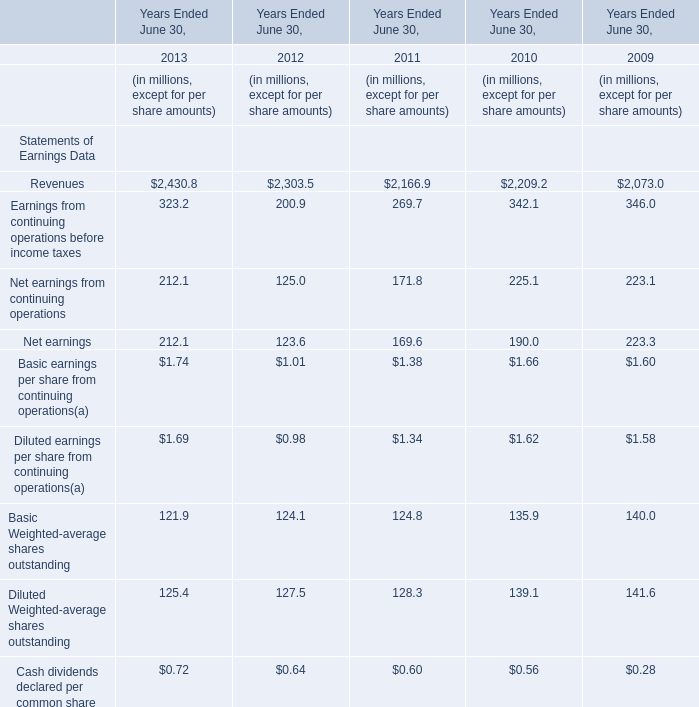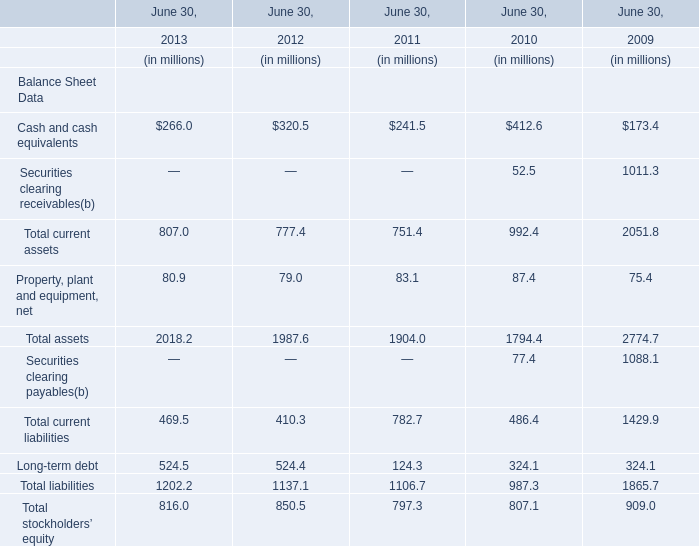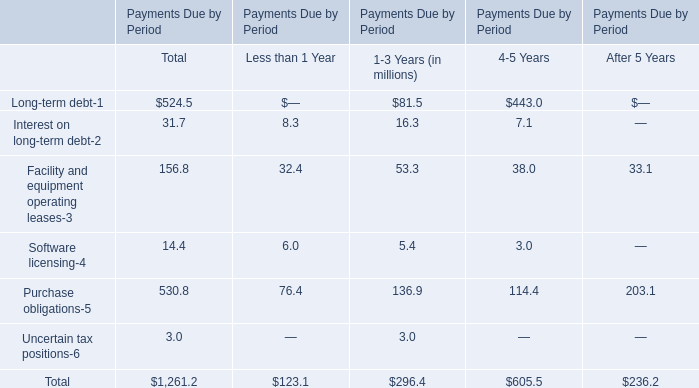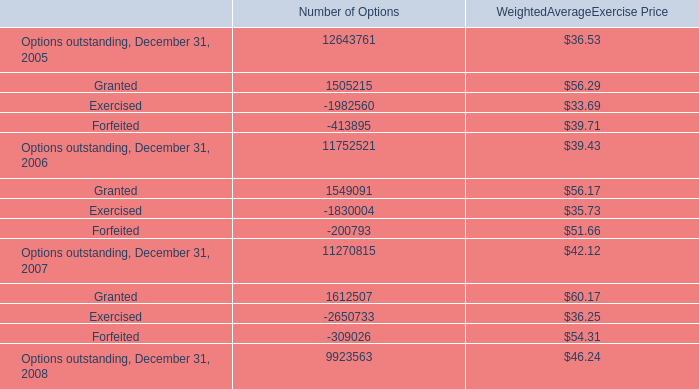What's the total amount of the Revenues in the years where Net earnings is greater than 170? (in millions) 
Computations: ((2430.8 + 2209.2) + 2073.0)
Answer: 6713.0. 